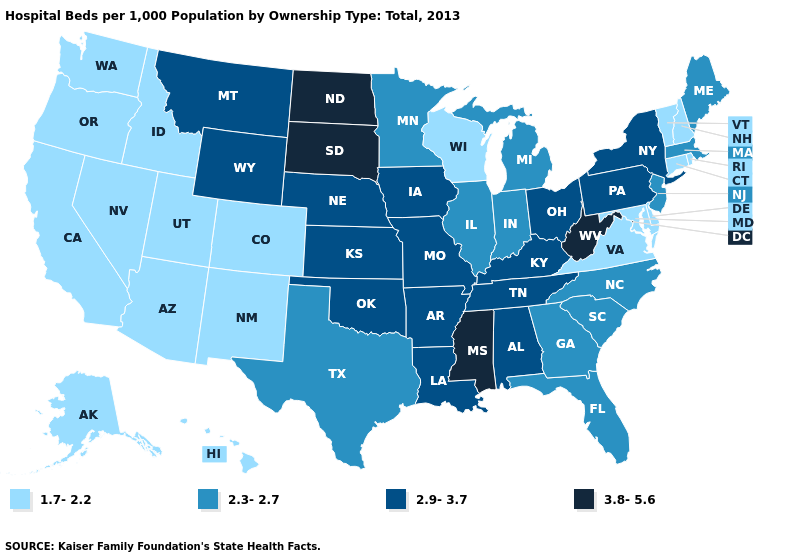What is the lowest value in the USA?
Quick response, please. 1.7-2.2. Does Colorado have the same value as Delaware?
Answer briefly. Yes. Does Washington have the lowest value in the USA?
Be succinct. Yes. What is the value of Texas?
Quick response, please. 2.3-2.7. Which states have the highest value in the USA?
Write a very short answer. Mississippi, North Dakota, South Dakota, West Virginia. Does Missouri have a lower value than South Dakota?
Short answer required. Yes. Name the states that have a value in the range 1.7-2.2?
Give a very brief answer. Alaska, Arizona, California, Colorado, Connecticut, Delaware, Hawaii, Idaho, Maryland, Nevada, New Hampshire, New Mexico, Oregon, Rhode Island, Utah, Vermont, Virginia, Washington, Wisconsin. Does Indiana have the same value as Louisiana?
Be succinct. No. What is the lowest value in the USA?
Concise answer only. 1.7-2.2. Does Arkansas have the highest value in the USA?
Answer briefly. No. How many symbols are there in the legend?
Be succinct. 4. Does Indiana have the highest value in the MidWest?
Be succinct. No. What is the value of Montana?
Give a very brief answer. 2.9-3.7. Name the states that have a value in the range 1.7-2.2?
Be succinct. Alaska, Arizona, California, Colorado, Connecticut, Delaware, Hawaii, Idaho, Maryland, Nevada, New Hampshire, New Mexico, Oregon, Rhode Island, Utah, Vermont, Virginia, Washington, Wisconsin. Among the states that border Louisiana , does Arkansas have the lowest value?
Keep it brief. No. 